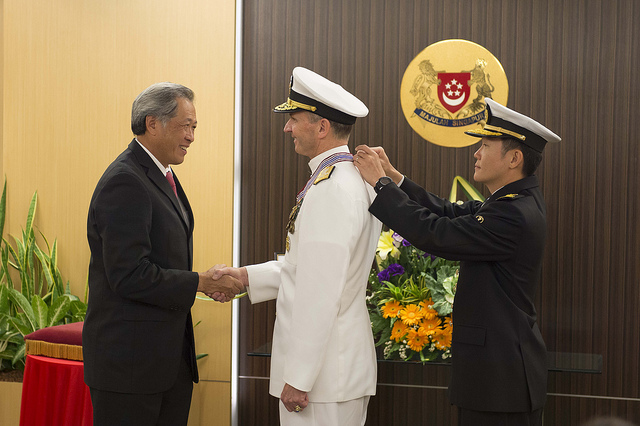Identify the text displayed in this image. MARAAN 